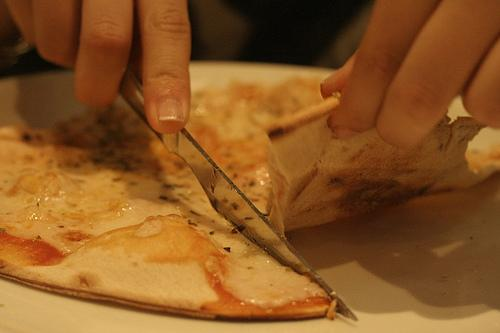What kind of pizza is in the image, and how can you tell? It is a small, cheese-covered flatbread pizza with white cheese, red sauce, and brown flakes as toppings, and thin white crust with some burnt marks. Based on the image, what could you say about the person's fingernails? One fingernail on the right hand holding the knife is clear, short, and well-manicured; the index finger's fingernail on the left hand lifting the pizza slice appears white and clean. Describe some visual features of the knife and its purpose in the scene. The knife is silver with a reflective surface, showing the reflection of the pizza and its surroundings; it is being used to cut a piece of the pizza. What are some details you can observe on the pizza crust in this image? The pizza crust is thin and white, and it has some black marks or scorch marks, a doughy bubble, and a thin edge of brown crust. Identify any unique features of the pizza toppings or ingredients. Some noteworthy features include the melted cheese with seasoning flakes, the curve of tomato sauce at the pizza's edge, and the golden brown crusty bread. What happens to the shadow in the image as a result of the person's interaction with the pizza? Multiple shadows are cast on the white platter, including the shadow of the hand and the bread, due to the light source and the person's hands interacting with the pizza. Identify the main food item in the image and how it is being served. A small personal pizza on a white platter, served with toppings such as white cheese, red sauce, and brown flakes. In a complete sentence, describe the action that the left-hand is performing in the image. The left hand is lifting a pizza slice while the person is cutting the pizza with a silver knife. Describe the overall scene depicted in the image, focusing on the person's hands. A person's hands are interacting with a pizza on a white platter – one hand holding a silver knife to cut the pizza, and the other lifting a pizza slice. What action is being performed on the main food item? A person is cutting the small personal pizza with a silver knife while holding down a slice with their other hand. 